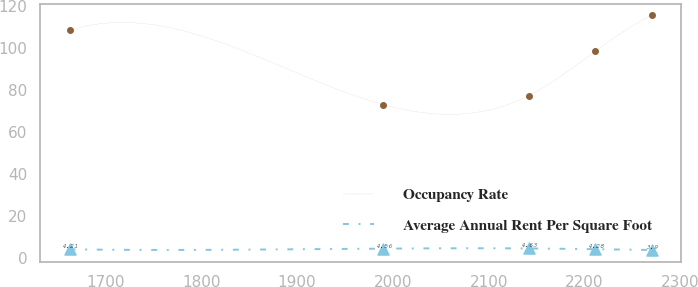Convert chart to OTSL. <chart><loc_0><loc_0><loc_500><loc_500><line_chart><ecel><fcel>Occupancy Rate<fcel>Average Annual Rent Per Square Foot<nl><fcel>1662.54<fcel>108.49<fcel>4.21<nl><fcel>1989.86<fcel>73.19<fcel>4.56<nl><fcel>2141.98<fcel>77.44<fcel>4.63<nl><fcel>2211.2<fcel>98.47<fcel>4.28<nl><fcel>2270.26<fcel>115.68<fcel>3.9<nl></chart> 